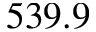Convert formula to latex. <formula><loc_0><loc_0><loc_500><loc_500>5 3 9 . 9</formula> 